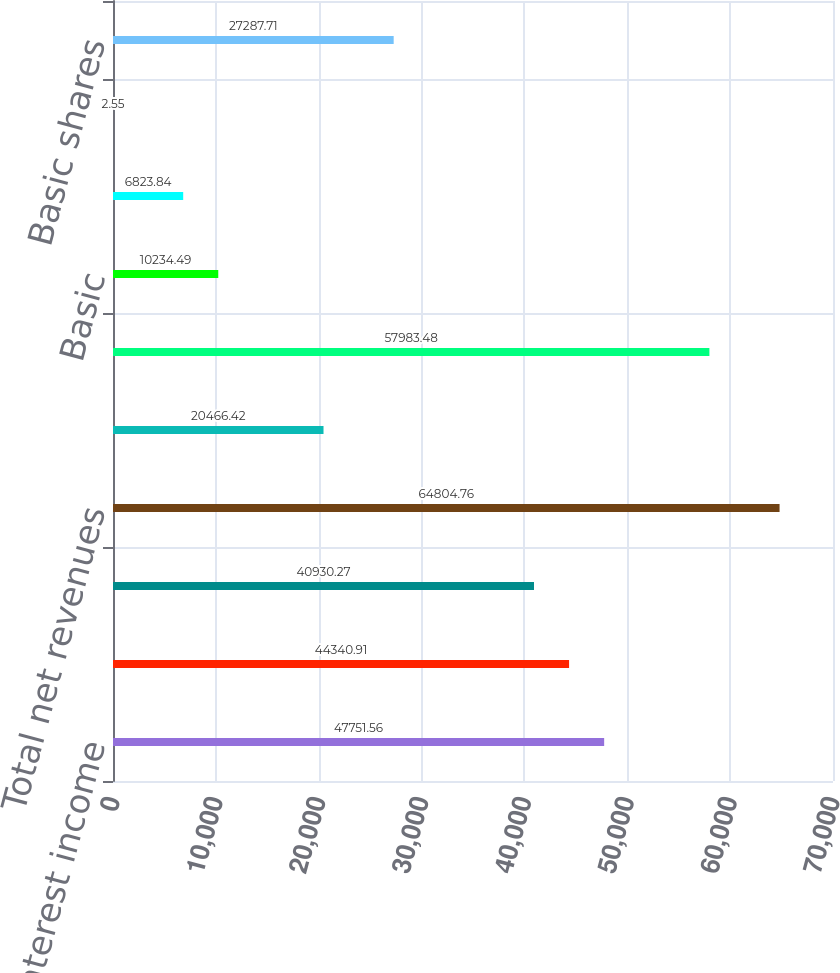Convert chart. <chart><loc_0><loc_0><loc_500><loc_500><bar_chart><fcel>Interest income<fcel>Interest expense<fcel>Net interest income<fcel>Total net revenues<fcel>Provision for credit losses<fcel>Operating expenses<fcel>Basic<fcel>Diluted<fcel>Dividends declared per common<fcel>Basic shares<nl><fcel>47751.6<fcel>44340.9<fcel>40930.3<fcel>64804.8<fcel>20466.4<fcel>57983.5<fcel>10234.5<fcel>6823.84<fcel>2.55<fcel>27287.7<nl></chart> 